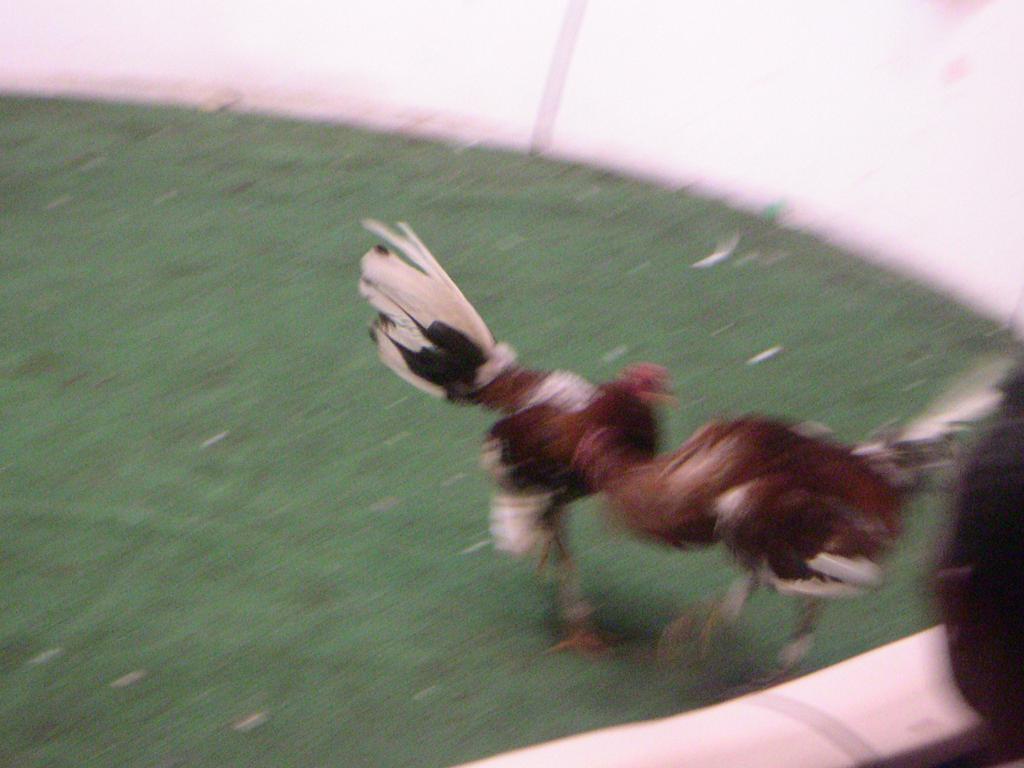Could you give a brief overview of what you see in this image? In this image there are two hens, there is grass towards the left of the image, there is a wall towards the top of the image, there is an object towards the right of the image, there is an object towards the bottom of the image. 